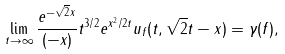Convert formula to latex. <formula><loc_0><loc_0><loc_500><loc_500>& \lim _ { t \to \infty } \frac { e ^ { - \sqrt { 2 } x } } { ( - x ) } t ^ { 3 / 2 } e ^ { x ^ { 2 } / 2 t } u _ { f } ( t , \sqrt { 2 } t - x ) = \gamma ( f ) ,</formula> 